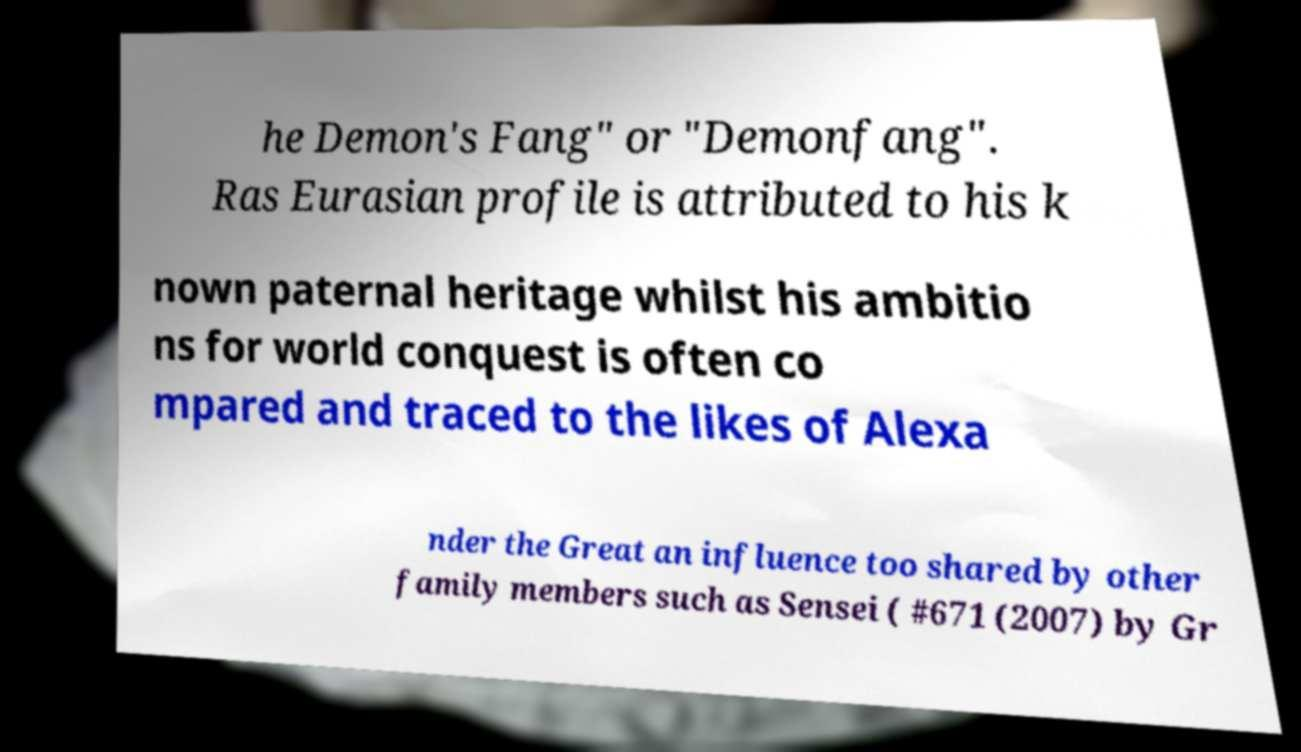Can you read and provide the text displayed in the image?This photo seems to have some interesting text. Can you extract and type it out for me? he Demon's Fang" or "Demonfang". Ras Eurasian profile is attributed to his k nown paternal heritage whilst his ambitio ns for world conquest is often co mpared and traced to the likes of Alexa nder the Great an influence too shared by other family members such as Sensei ( #671 (2007) by Gr 